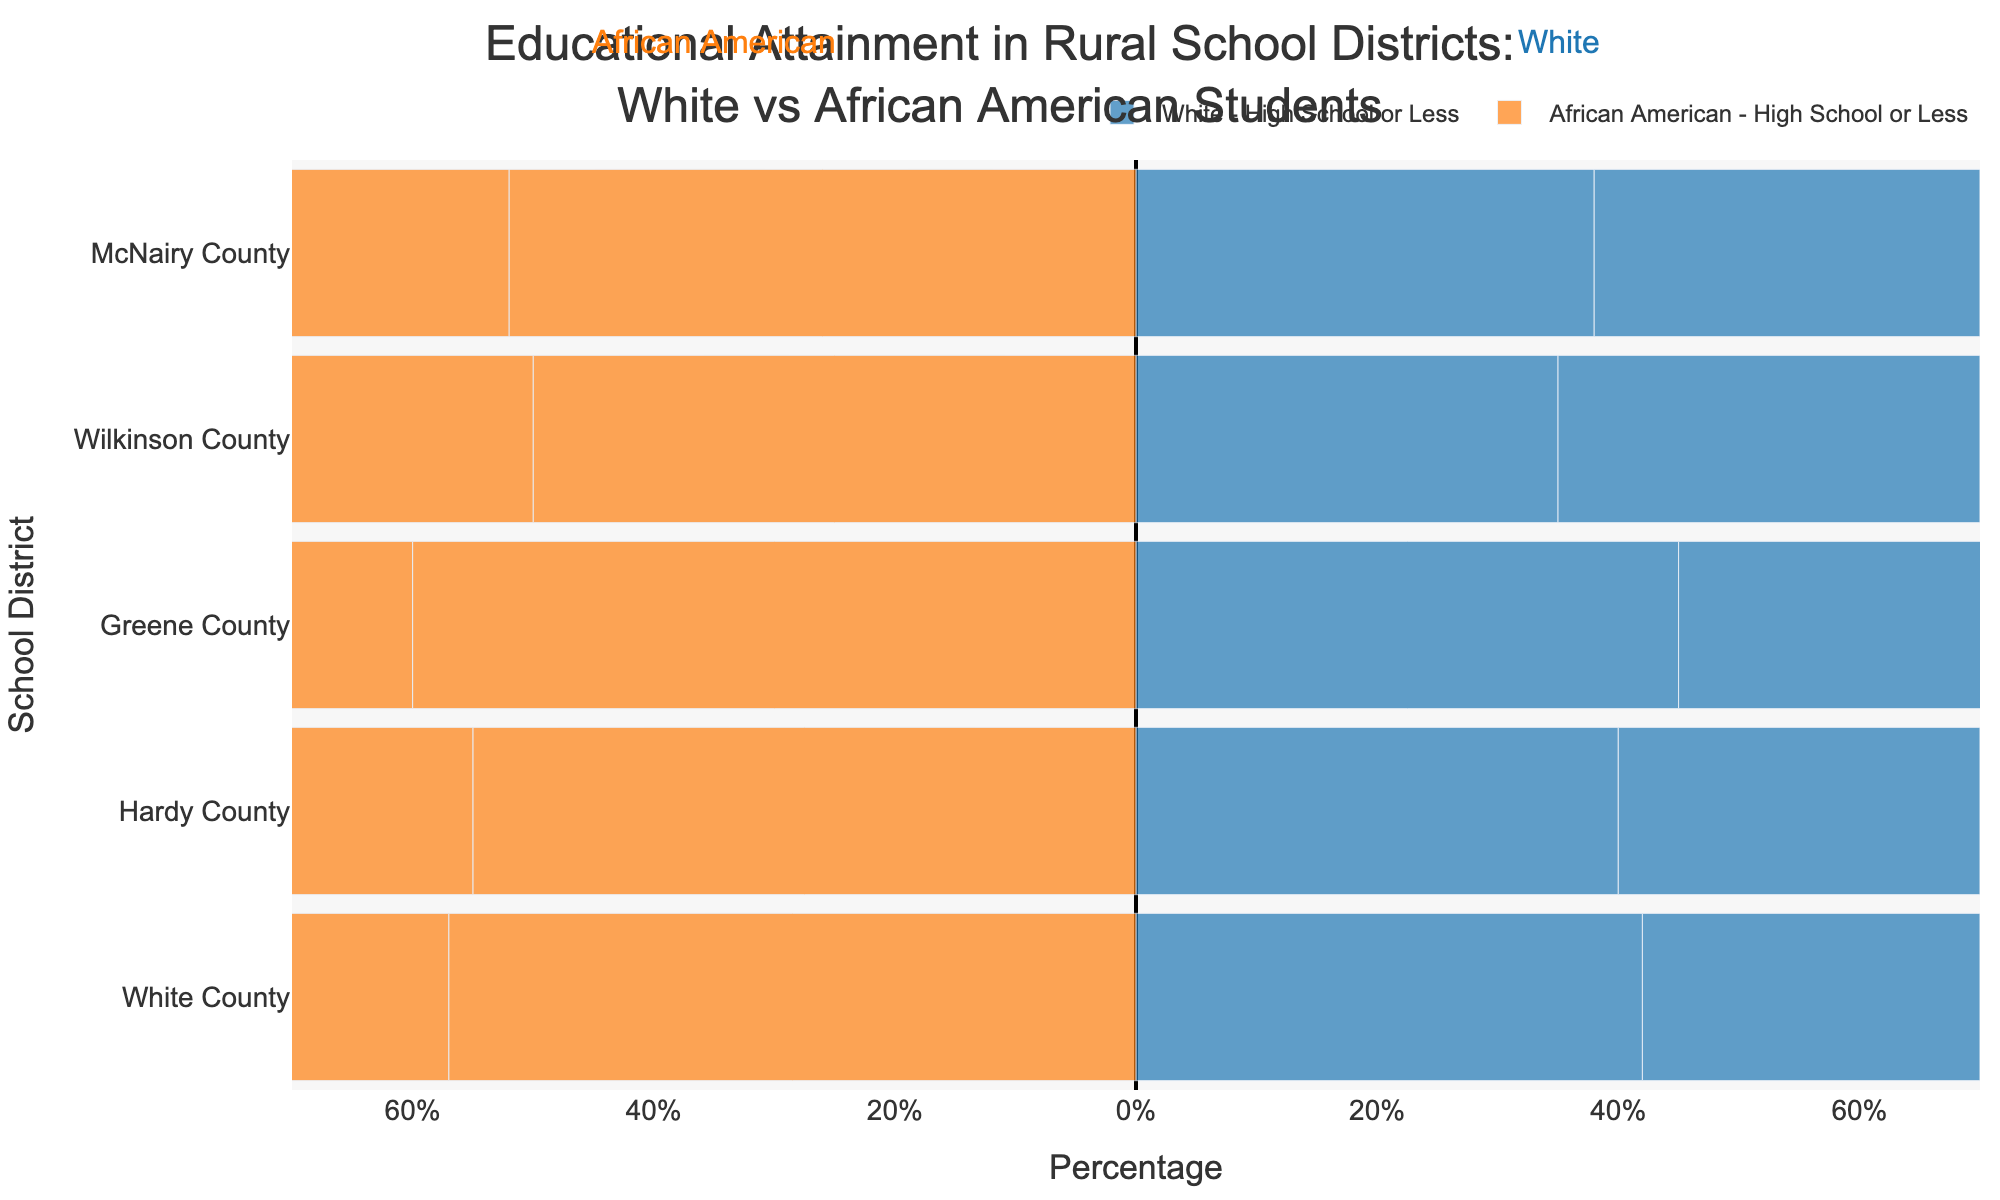Which school district has the highest percentage of African American students with a Bachelor’s Degree or more? By examining the lengths of the bars that represent the African American students with a Bachelor’s Degree or more across all school districts, the district with the longest bar shows the highest percentage. McNairy County has the longest bar in this category.
Answer: McNairy County Compare the percentage of White students with Some College education in Hardy County to African American students with Some College education in the same district. In Hardy County, the bar representing White students with Some College is 30% to the right, while the bar representing African American students with Some College is 25% to the left. Since the left side represents negative percentages for African Americans, this means 25 percent for African Americans.
Answer: 30% (White) vs 25% (African American) Which race generally has a higher percentage of students with only High School education or less in all school districts? For each school district, the bars representing African American students with only High School or less are longer than those for White students. This pattern indicates that African American students generally have a higher percentage with only High School education or less.
Answer: African American What is the median percentage of White students with Bachelor’s Degree or more across all school districts? The percentages of White students with Bachelor’s Degree or more are: 30% (Hardy County), 25% (Greene County), 30% (Wilkinson County), 30% (McNairy County), and 30% (White County). Ordering these values: [25%, 30%, 30%, 30%, 30%], the median value is the third one.
Answer: 30% Calculate the difference between the percentage of African American students and White students with High School education or less in Greene County. In Greene County, the percentage of African American students with High School or less is shown as 60%, and for White students, it is 45%. The difference is calculated as 60% - 45%.
Answer: 15% Which district has the smallest difference between the percentages of White students and African American students with Some College education? By comparing the lengths of the bars for Some College education in each district, Harding County shows a difference of 30% (White) vs 25% (African American), a difference of 5%, which is the smallest among all districts.
Answer: Hardy County How does the educational attainment of African American students in White County with Bachelor’s Degree or more compare to the national norm (assuming it’s around 25%)? The bar for African American students in White County with Bachelor’s Degree or more is at 16%. Comparing this to the national norm of 25%, it is evident that White County's percentage is lower.
Answer: Lower What is the average percentage of White students with Some College across all analyzed school districts? The percentages of White students with Some College in the school districts are: 30% (Hardy County), 30% (Greene County), 35% (Wilkinson County), 32% (McNairy County), and 28% (White County). The sum of these values is 155%. Dividing the sum by 5 (the number of districts) gives the average percentage.
Answer: 31% In McNairy County, which educational category has the highest percentage for African American students? The visual comparison of bar lengths for African Americans in McNairy County shows that "High School or Less" has the highest percentage, as the bar is the longest.
Answer: High School or Less 